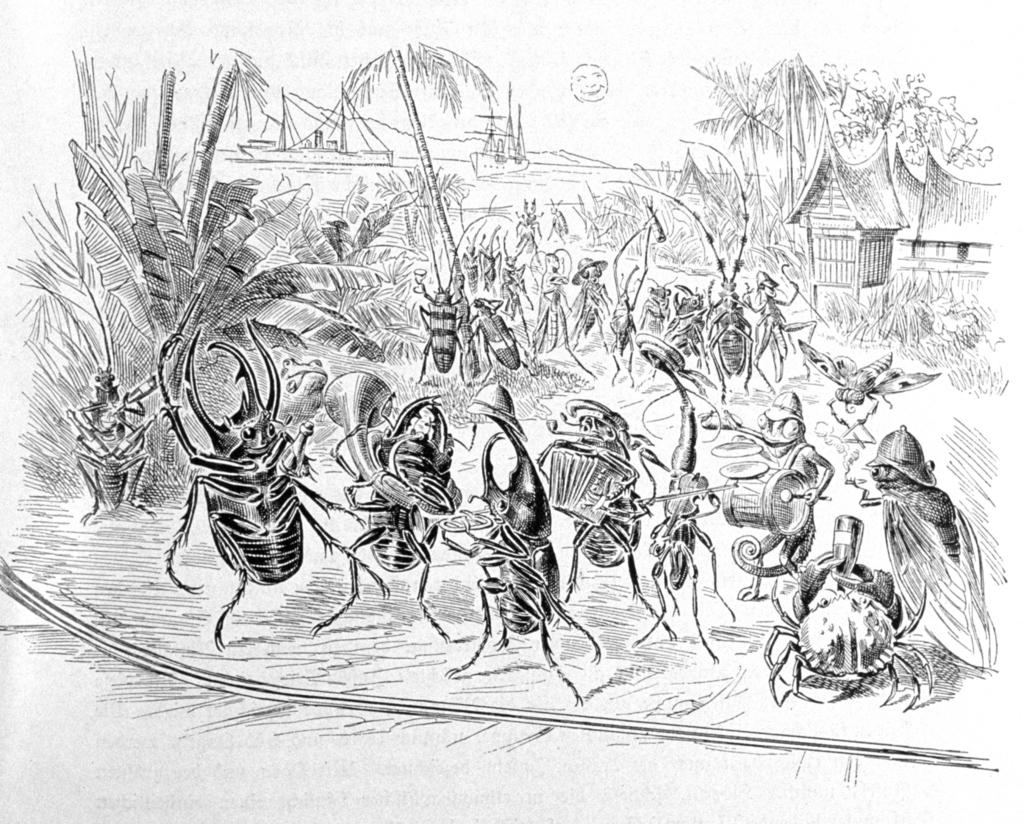What type of artwork is depicted in the image? The image is a drawing. What are the insects in the drawing doing? The insects are playing musical instruments in the drawing. What type of natural elements can be seen in the drawing? There are plants and trees in the drawing. What can be seen in the background of the drawing? There are ships in the background of the drawing. Where is the hut located in the drawing? The hut is on the right side of the drawing. What type of meat is being sold on the sidewalk in the drawing? There is no sidewalk or meat present in the drawing; it features insects playing musical instruments, plants, trees, ships, and a hut. 